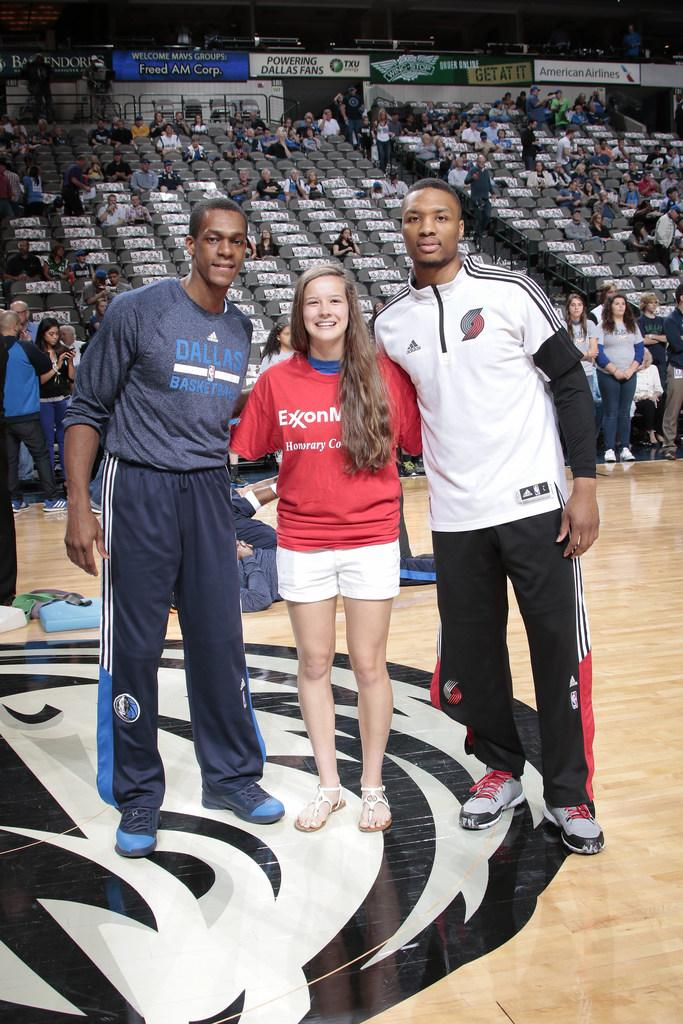<image>
Write a terse but informative summary of the picture. Three people possig for a picture and one of them have a sweater from Dallas basketball. 